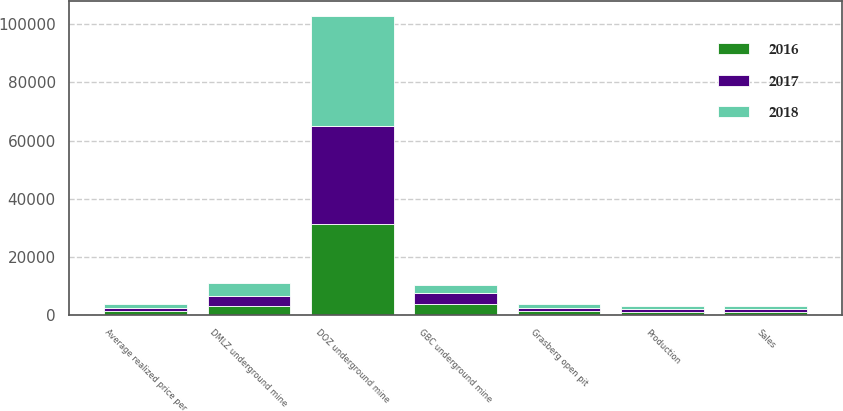Convert chart to OTSL. <chart><loc_0><loc_0><loc_500><loc_500><stacked_bar_chart><ecel><fcel>Production<fcel>Sales<fcel>Average realized price per<fcel>Grasberg open pit<fcel>DOZ underground mine<fcel>DMLZ underground mine<fcel>GBC underground mine<nl><fcel>2017<fcel>1160<fcel>1130<fcel>1254<fcel>1254<fcel>33800<fcel>3200<fcel>4000<nl><fcel>2016<fcel>984<fcel>981<fcel>1268<fcel>1254<fcel>31200<fcel>3200<fcel>3600<nl><fcel>2018<fcel>1063<fcel>1054<fcel>1237<fcel>1254<fcel>38000<fcel>4400<fcel>2700<nl></chart> 